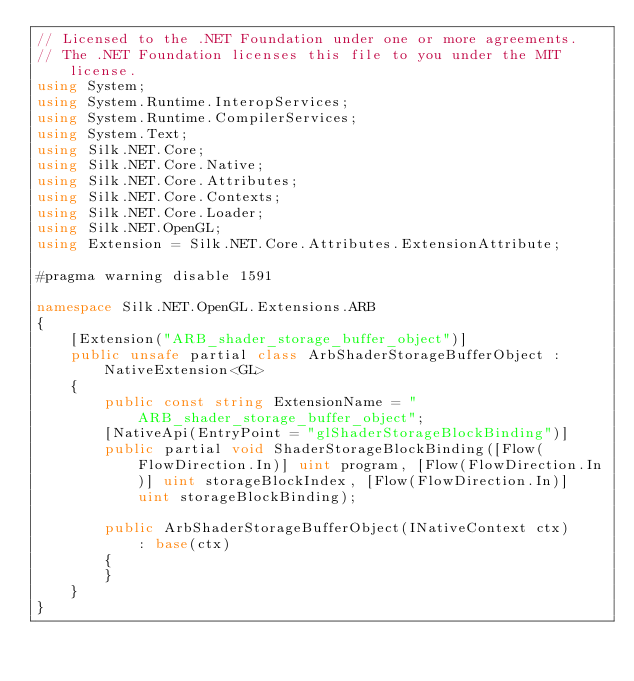Convert code to text. <code><loc_0><loc_0><loc_500><loc_500><_C#_>// Licensed to the .NET Foundation under one or more agreements.
// The .NET Foundation licenses this file to you under the MIT license.
using System;
using System.Runtime.InteropServices;
using System.Runtime.CompilerServices;
using System.Text;
using Silk.NET.Core;
using Silk.NET.Core.Native;
using Silk.NET.Core.Attributes;
using Silk.NET.Core.Contexts;
using Silk.NET.Core.Loader;
using Silk.NET.OpenGL;
using Extension = Silk.NET.Core.Attributes.ExtensionAttribute;

#pragma warning disable 1591

namespace Silk.NET.OpenGL.Extensions.ARB
{
    [Extension("ARB_shader_storage_buffer_object")]
    public unsafe partial class ArbShaderStorageBufferObject : NativeExtension<GL>
    {
        public const string ExtensionName = "ARB_shader_storage_buffer_object";
        [NativeApi(EntryPoint = "glShaderStorageBlockBinding")]
        public partial void ShaderStorageBlockBinding([Flow(FlowDirection.In)] uint program, [Flow(FlowDirection.In)] uint storageBlockIndex, [Flow(FlowDirection.In)] uint storageBlockBinding);

        public ArbShaderStorageBufferObject(INativeContext ctx)
            : base(ctx)
        {
        }
    }
}

</code> 